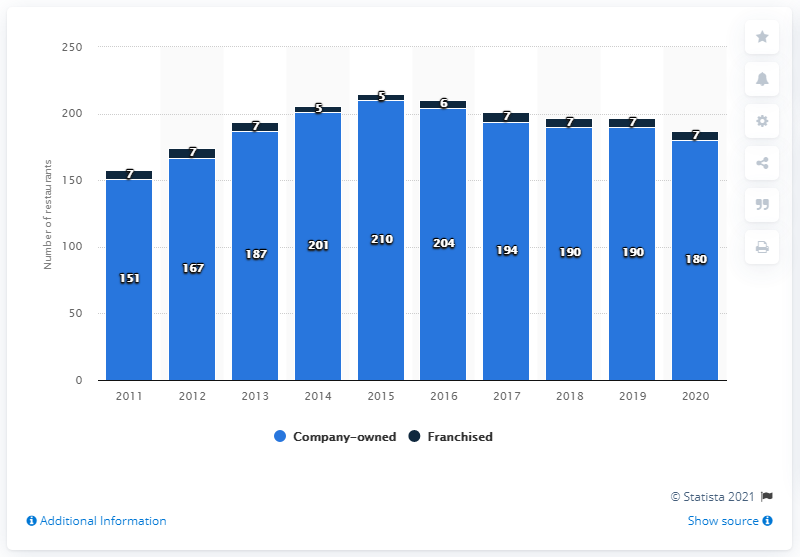Identify some key points in this picture. In the year 2020, Bonefish Grill had a total of 180 company-owned restaurants located in the United States. 